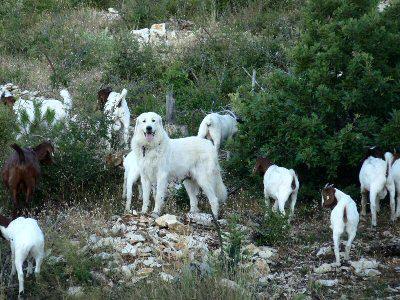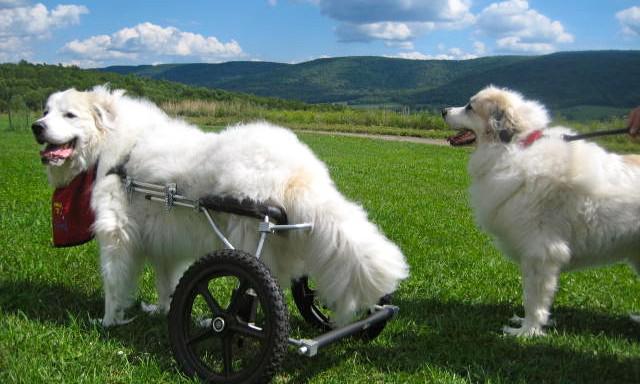The first image is the image on the left, the second image is the image on the right. Evaluate the accuracy of this statement regarding the images: "In one image, one dog is shown with a flock of goats.". Is it true? Answer yes or no. Yes. The first image is the image on the left, the second image is the image on the right. For the images shown, is this caption "There are exactly two dogs in the image on the right." true? Answer yes or no. Yes. 